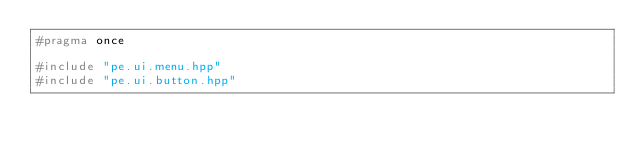Convert code to text. <code><loc_0><loc_0><loc_500><loc_500><_C++_>#pragma once

#include "pe.ui.menu.hpp"
#include "pe.ui.button.hpp"</code> 